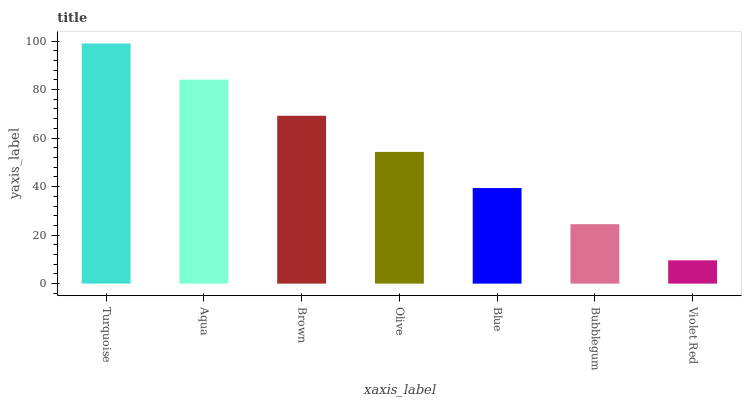Is Violet Red the minimum?
Answer yes or no. Yes. Is Turquoise the maximum?
Answer yes or no. Yes. Is Aqua the minimum?
Answer yes or no. No. Is Aqua the maximum?
Answer yes or no. No. Is Turquoise greater than Aqua?
Answer yes or no. Yes. Is Aqua less than Turquoise?
Answer yes or no. Yes. Is Aqua greater than Turquoise?
Answer yes or no. No. Is Turquoise less than Aqua?
Answer yes or no. No. Is Olive the high median?
Answer yes or no. Yes. Is Olive the low median?
Answer yes or no. Yes. Is Aqua the high median?
Answer yes or no. No. Is Blue the low median?
Answer yes or no. No. 